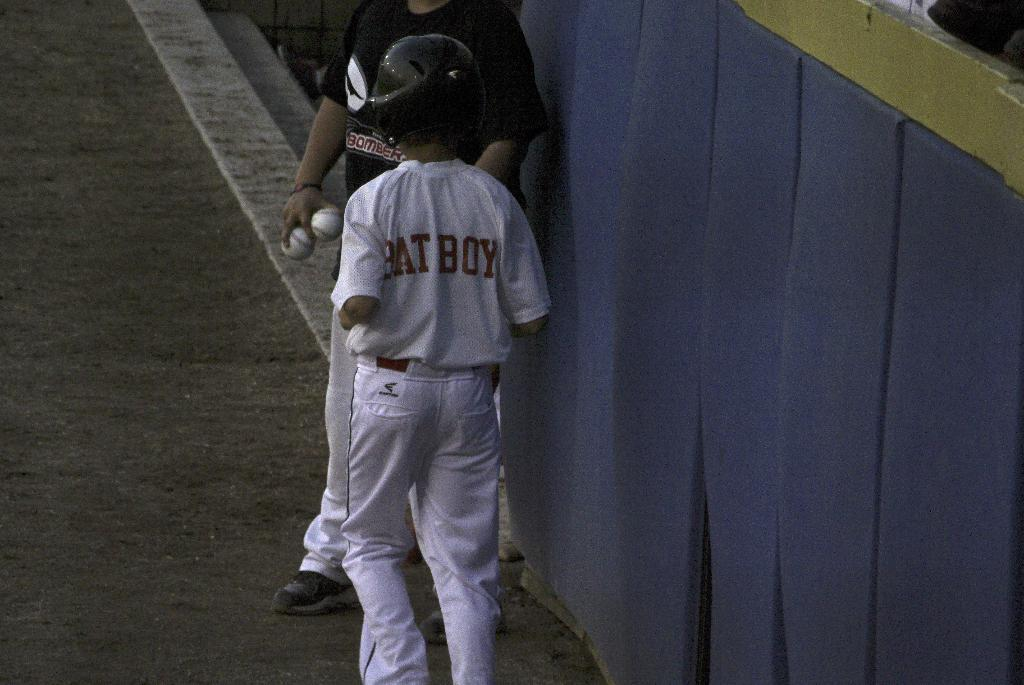<image>
Relay a brief, clear account of the picture shown. A baseball player wears a uniform that says bat boy on the back. 